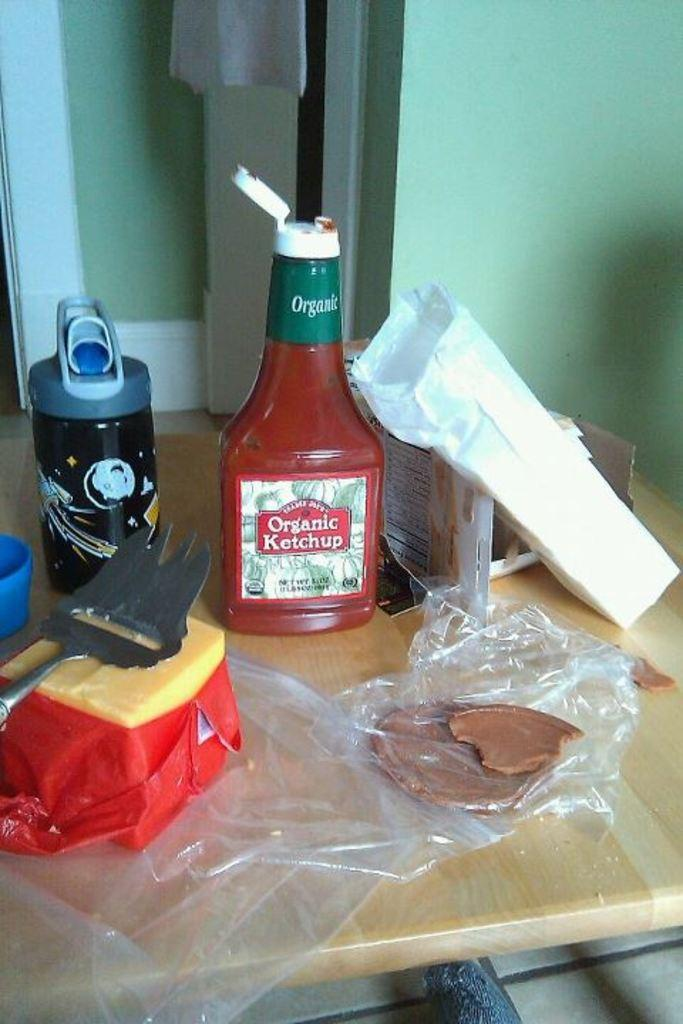<image>
Describe the image concisely. A bottle of Organic Ketchip is sitting on a table in front of a block of cheese 